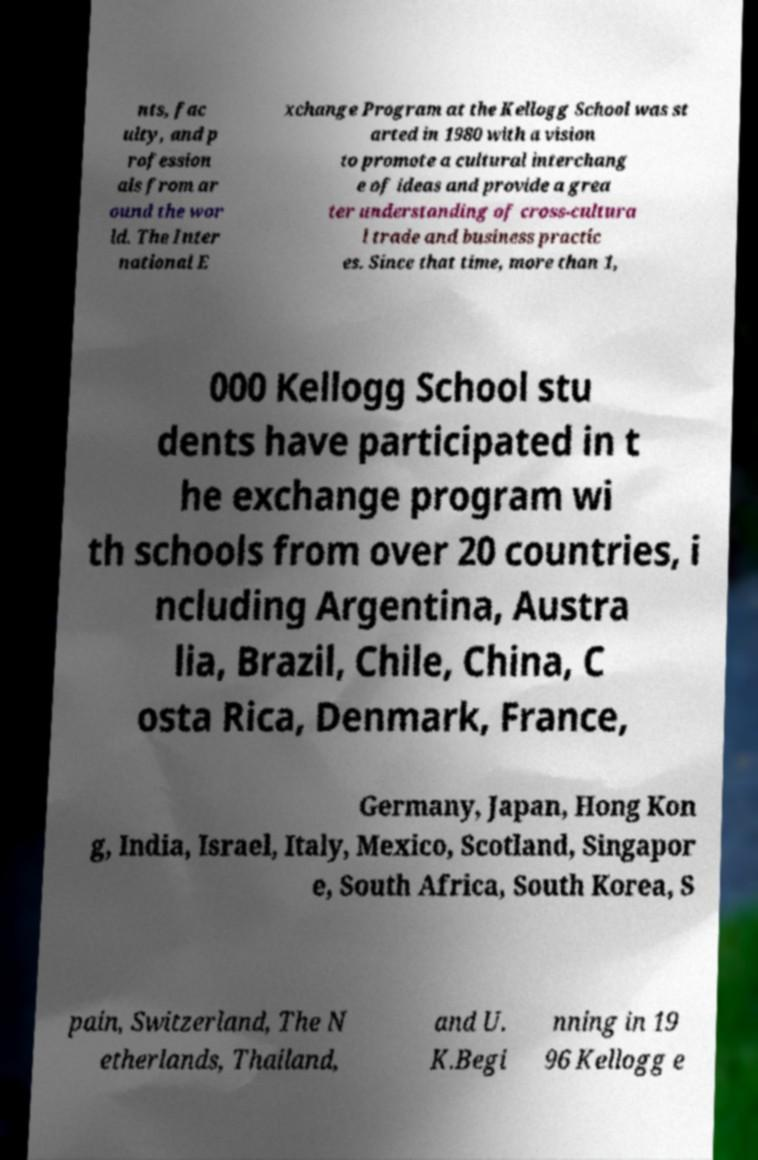Please read and relay the text visible in this image. What does it say? nts, fac ulty, and p rofession als from ar ound the wor ld. The Inter national E xchange Program at the Kellogg School was st arted in 1980 with a vision to promote a cultural interchang e of ideas and provide a grea ter understanding of cross-cultura l trade and business practic es. Since that time, more than 1, 000 Kellogg School stu dents have participated in t he exchange program wi th schools from over 20 countries, i ncluding Argentina, Austra lia, Brazil, Chile, China, C osta Rica, Denmark, France, Germany, Japan, Hong Kon g, India, Israel, Italy, Mexico, Scotland, Singapor e, South Africa, South Korea, S pain, Switzerland, The N etherlands, Thailand, and U. K.Begi nning in 19 96 Kellogg e 